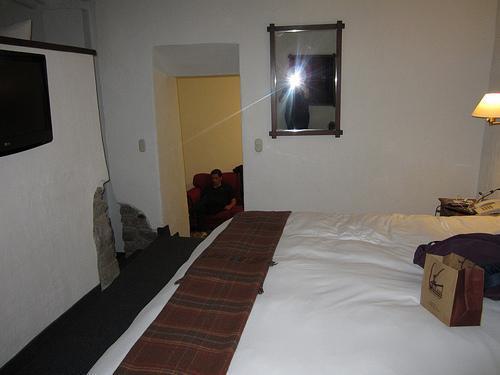How many beds?
Give a very brief answer. 1. 